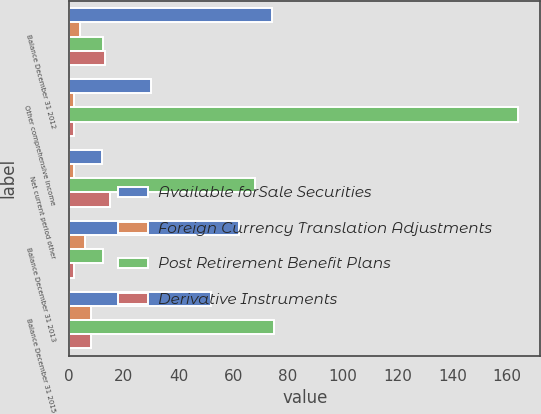Convert chart. <chart><loc_0><loc_0><loc_500><loc_500><stacked_bar_chart><ecel><fcel>Balance December 31 2012<fcel>Other comprehensive income<fcel>Net current period other<fcel>Balance December 31 2013<fcel>Balance December 31 2015<nl><fcel>Available forSale Securities<fcel>74<fcel>30<fcel>12<fcel>62<fcel>52<nl><fcel>Foreign Currency Translation Adjustments<fcel>4<fcel>2<fcel>2<fcel>6<fcel>8<nl><fcel>Post Retirement Benefit Plans<fcel>12.5<fcel>164<fcel>68<fcel>12.5<fcel>75<nl><fcel>Derivative Instruments<fcel>13<fcel>2<fcel>15<fcel>2<fcel>8<nl></chart> 